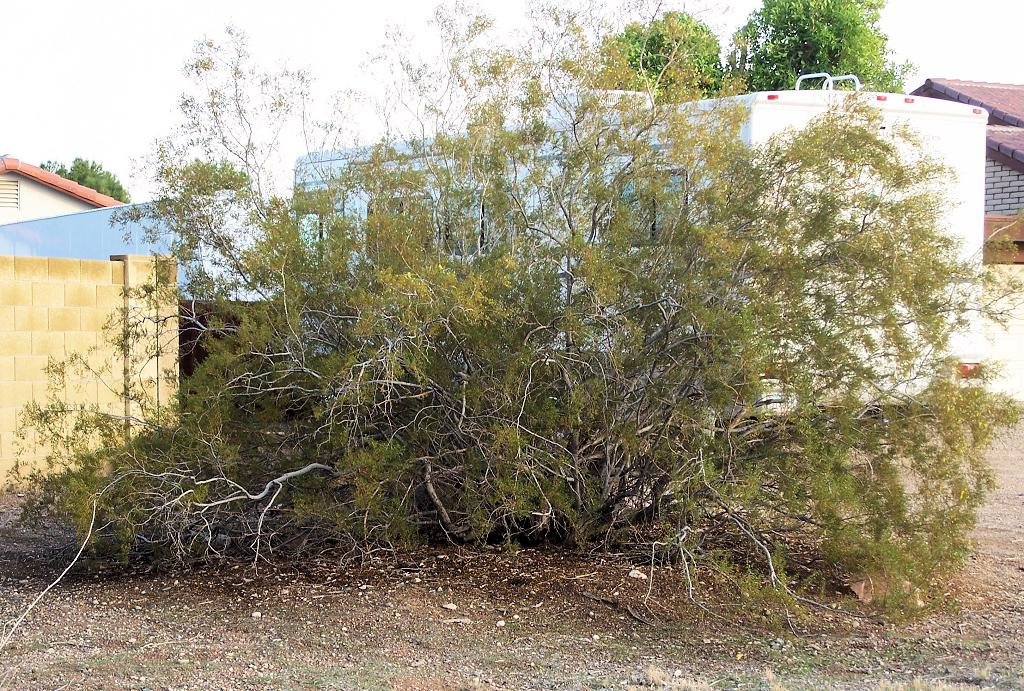What type of vegetation can be seen in the image? There are trees in the image. What structure is present in the image? There is a wall in the image. What type of buildings can be seen in the image? There are houses visible in the image. What is visible at the top of the image? The sky is visible at the top of the image. What is the opinion of the father about the houses in the image? There is no father present in the image, and therefore no opinion can be attributed to him. What type of roof can be seen on the houses in the image? The provided facts do not mention the type of roof on the houses, so it cannot be determined from the image. 